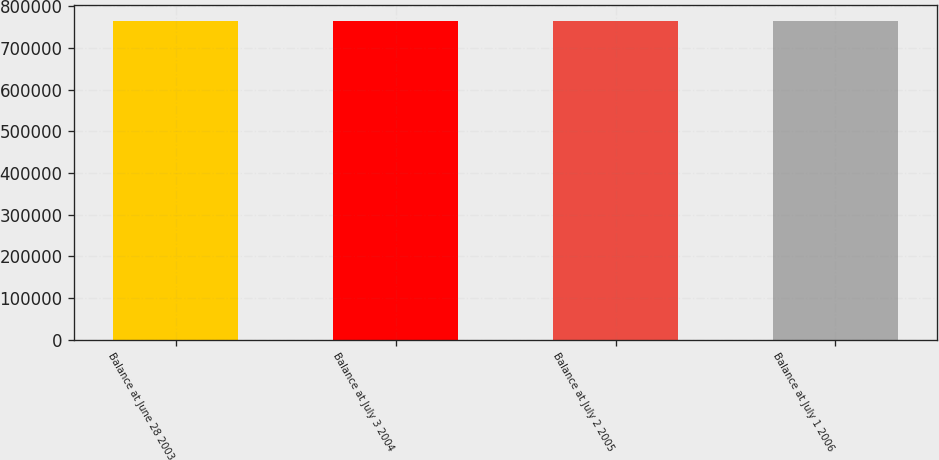Convert chart. <chart><loc_0><loc_0><loc_500><loc_500><bar_chart><fcel>Balance at June 28 2003<fcel>Balance at July 3 2004<fcel>Balance at July 2 2005<fcel>Balance at July 1 2006<nl><fcel>765175<fcel>765175<fcel>765175<fcel>765175<nl></chart> 